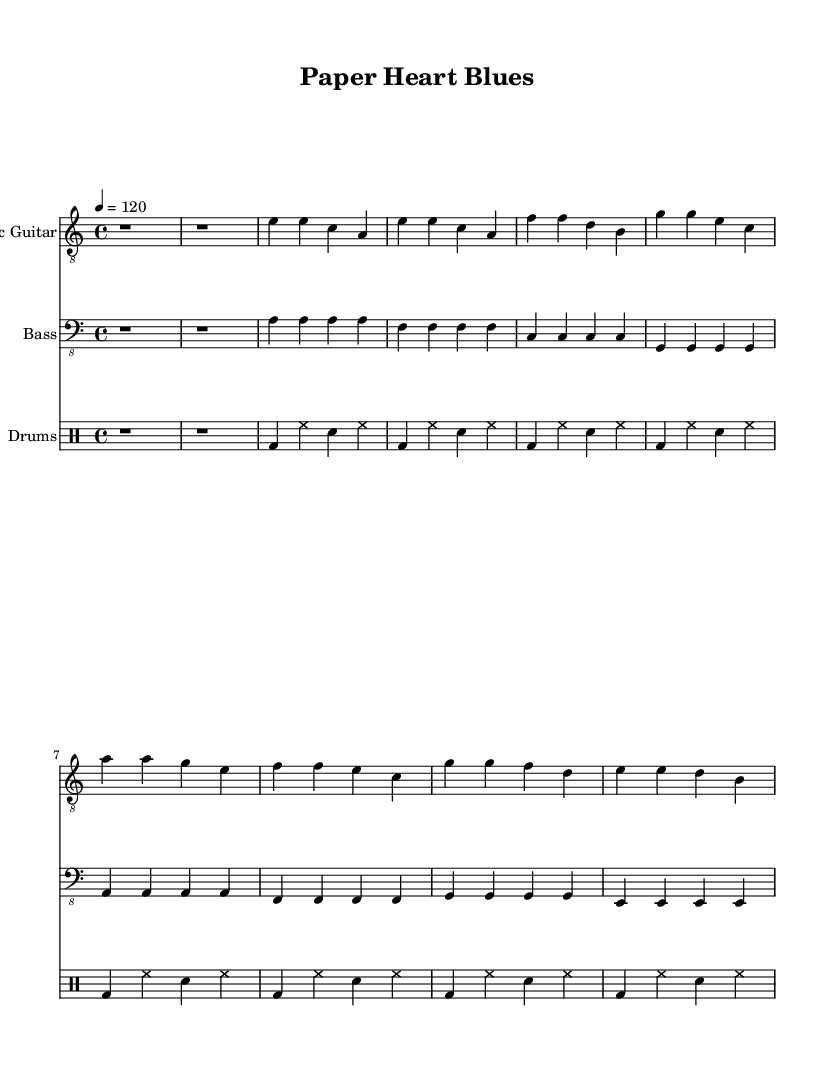What is the key signature of this music? The key signature is A minor, which has no sharps or flats.
Answer: A minor What is the time signature of the piece? The time signature is indicated as 4/4, meaning there are four beats in each measure.
Answer: 4/4 What is the tempo marking of this piece? The tempo marking is indicated as "4 = 120", which means there are 120 beats per minute.
Answer: 120 How many measures are there in the section for the electric guitar? The electric guitar part has a total of 8 measures in both the verse and chorus sections combined. Counting each measure in the electric guitar section reveals that there are 4 measures for the verse and 4 measures for the chorus.
Answer: 8 measures What type of drum pattern is used in this piece? The drum pattern includes a bass drum on the first beat, hi-hat sounds on the eighth notes, and snare hits on the backbeat, typical in blues and pop fusion. This rhythm creates the characteristic groove of the style.
Answer: Bass and hi-hat with snare What is the primary structure of the song? The primary structure consists of an intro followed by verses and choruses, alternating between them, which is typical in many modern songs. This structure allows for emotional storytelling through the lyrics and instrumental sections.
Answer: Intro, Verse, Chorus How does the bass guitar contribute to the overall sound? The bass guitar provides a solid foundation to the harmony, with a walking bassline pattern that complements the electric guitar and drums, maintaining the groove integral to blues music while adding a pop flair.
Answer: Foundation and groove 